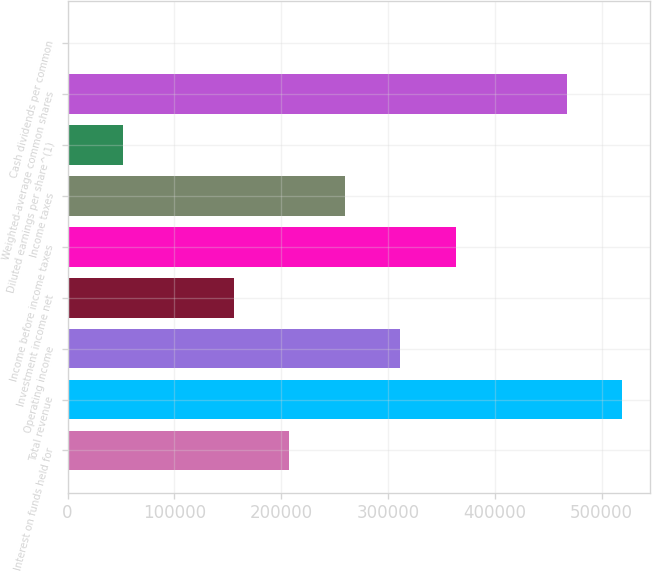Convert chart. <chart><loc_0><loc_0><loc_500><loc_500><bar_chart><fcel>Interest on funds held for<fcel>Total revenue<fcel>Operating income<fcel>Investment income net<fcel>Income before income taxes<fcel>Income taxes<fcel>Diluted earnings per share^(1)<fcel>Weighted-average common shares<fcel>Cash dividends per common<nl><fcel>207691<fcel>519228<fcel>311537<fcel>155769<fcel>363460<fcel>259614<fcel>51923.1<fcel>467305<fcel>0.3<nl></chart> 